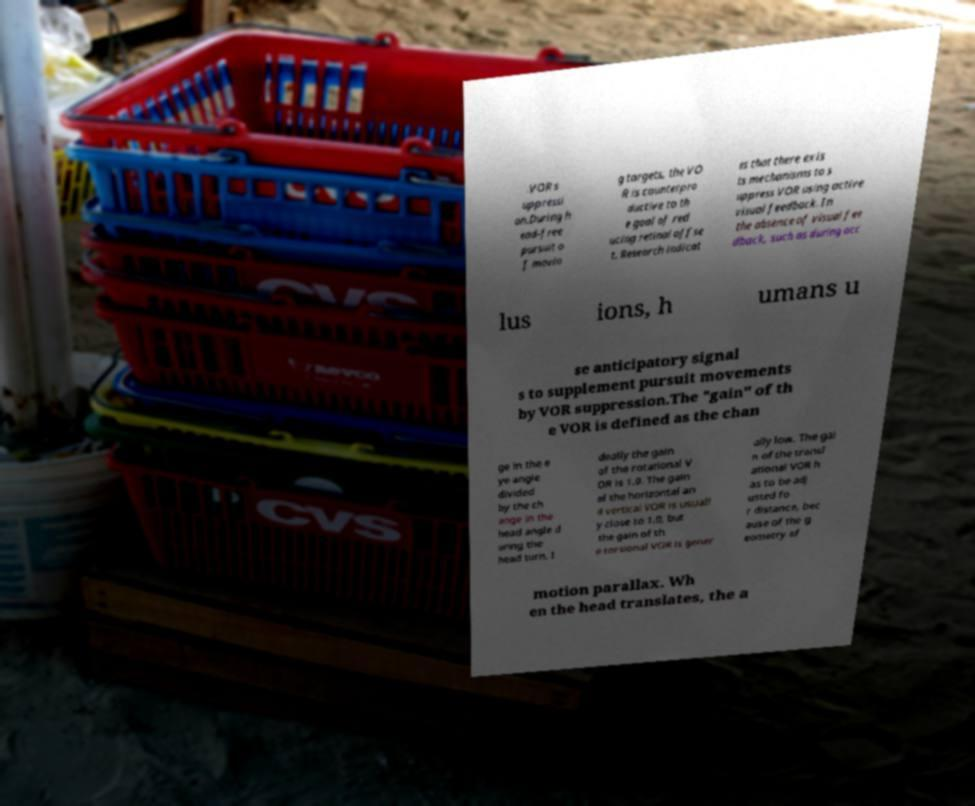Can you read and provide the text displayed in the image?This photo seems to have some interesting text. Can you extract and type it out for me? .VOR s uppressi on.During h ead-free pursuit o f movin g targets, the VO R is counterpro ductive to th e goal of red ucing retinal offse t. Research indicat es that there exis ts mechanisms to s uppress VOR using active visual feedback. In the absence of visual fee dback, such as during occ lus ions, h umans u se anticipatory signal s to supplement pursuit movements by VOR suppression.The "gain" of th e VOR is defined as the chan ge in the e ye angle divided by the ch ange in the head angle d uring the head turn. I deally the gain of the rotational V OR is 1.0. The gain of the horizontal an d vertical VOR is usuall y close to 1.0, but the gain of th e torsional VOR is gener ally low. The gai n of the transl ational VOR h as to be adj usted fo r distance, bec ause of the g eometry of motion parallax. Wh en the head translates, the a 